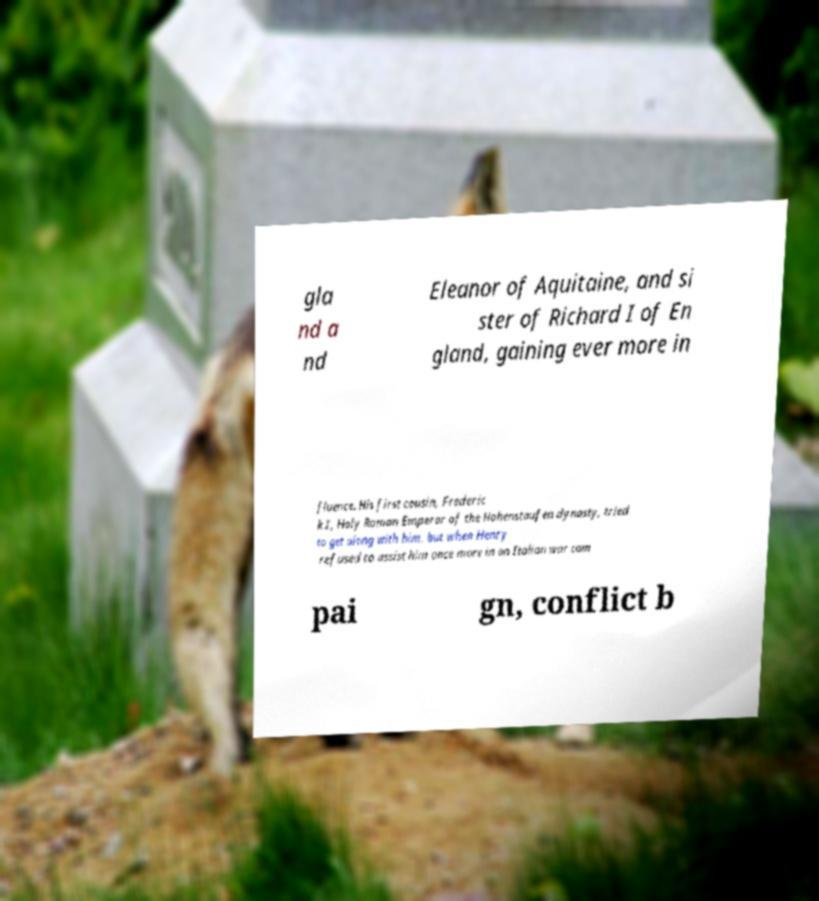Please identify and transcribe the text found in this image. gla nd a nd Eleanor of Aquitaine, and si ster of Richard I of En gland, gaining ever more in fluence. His first cousin, Frederic k I, Holy Roman Emperor of the Hohenstaufen dynasty, tried to get along with him, but when Henry refused to assist him once more in an Italian war cam pai gn, conflict b 